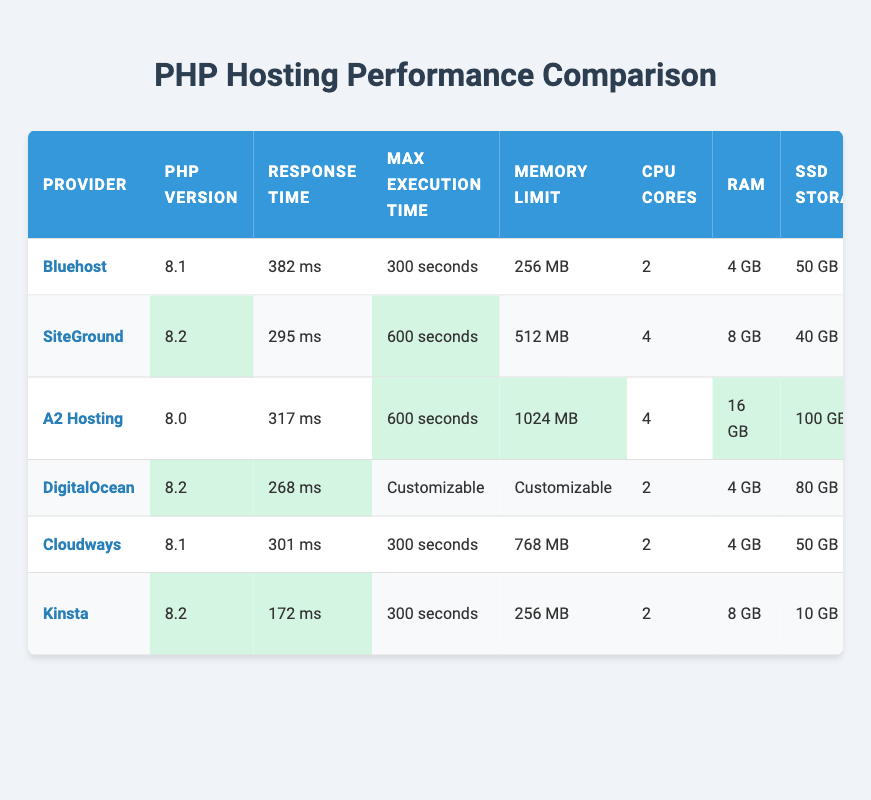What is the server response time for SiteGround? The server response time for SiteGround is listed in the table under the "Response Time" column. By locating SiteGround in the first column and reading across to the response time, we find it is 295 ms.
Answer: 295 ms Which hosting provider has the highest memory limit? To find the highest memory limit, we need to compare the values in the "Memory Limit" column across all providers. The maximum value identified is 1024 MB for A2 Hosting.
Answer: A2 Hosting Is the monthly traffic for Bluehost unmetered? The entry for monthly traffic for Bluehost shows "Unmetered" in that column. This confirms that the monthly traffic for Bluehost is indeed unmetered.
Answer: Yes What is the average price per month among the listed providers? First, we need to extract the price per month from each provider: $19.99 (Bluehost), $29.99 (SiteGround), $25.99 (A2 Hosting), $20 (DigitalOcean), $22 (Cloudways), $30 (Kinsta). Adding these amounts gives $19.99 + $29.99 + $25.99 + $20 + $22 + $30 = $148.96. Now, dividing $148.96 by the number of providers (6) gives an average of approximately $24.83.
Answer: $24.83 How many providers have a PHP version higher than 8.1? We must look through the "PHP Version" column and identify the entries higher than 8.1. The relevant rows are SiteGround (8.2), DigitalOcean (8.2), and Kinsta (8.2). Thus, there are 3 providers with a PHP version higher than 8.1.
Answer: 3 Which hosting provider has the least amount of SSD storage? We will compare the "SSD Storage" values listed for each provider. The smallest value comes from Kinsta, which has 10 GB of SSD storage.
Answer: Kinsta What is the difference in uptime between DigitalOcean and Cloudways? The uptime for DigitalOcean is 99.99%, while for Cloudways it is also 99.99%. Calculating the difference gives us 99.99% - 99.99% = 0%.
Answer: 0% Which provider offers the most CPU cores? By checking the "CPU Cores" column, we see SiteGround, A2 Hosting, and DigitalOcean all offer 4 CPU cores, which is the highest among all providers listed.
Answer: SiteGround, A2 Hosting, DigitalOcean Does any provider offer customizable max execution time? Looking at the "Max Execution Time" column, only DigitalOcean lists "Customizable," while all others have fixed time limits. This indicates that there is indeed one provider with a customizable option.
Answer: Yes 